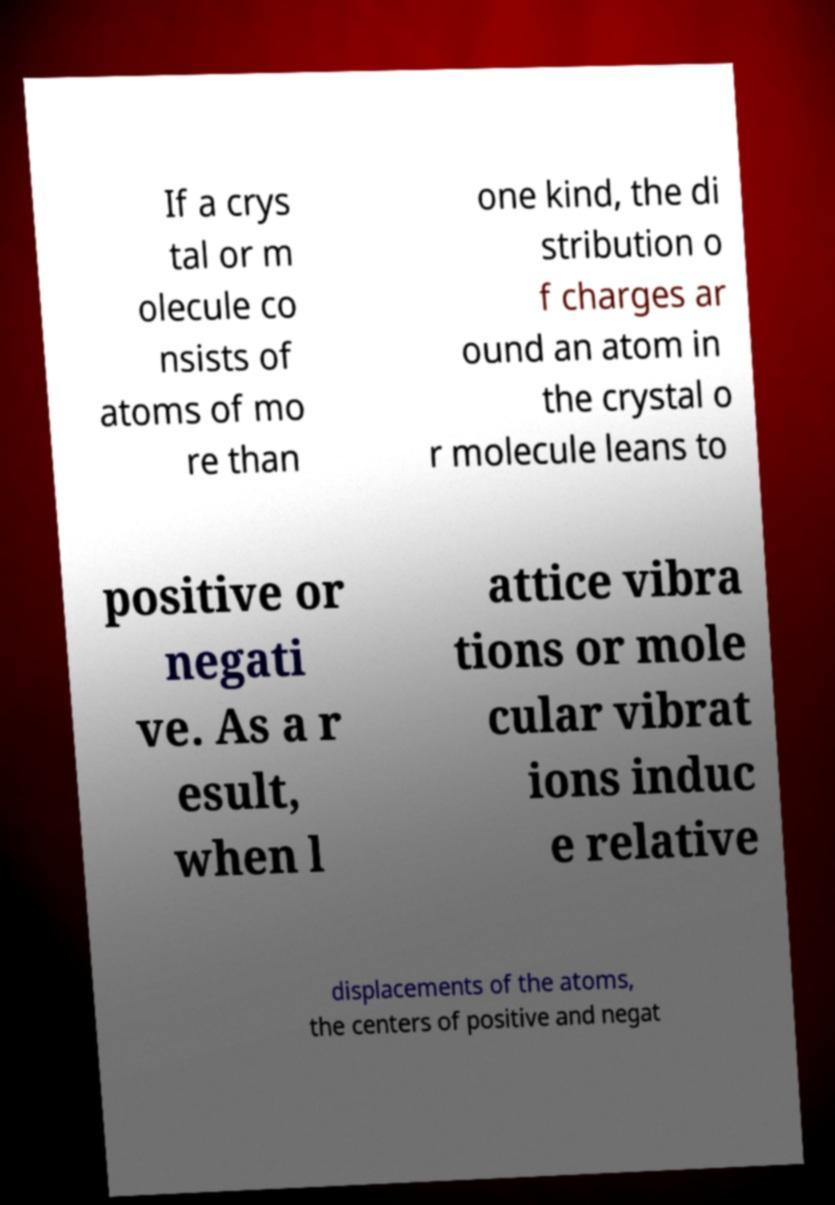Can you read and provide the text displayed in the image?This photo seems to have some interesting text. Can you extract and type it out for me? If a crys tal or m olecule co nsists of atoms of mo re than one kind, the di stribution o f charges ar ound an atom in the crystal o r molecule leans to positive or negati ve. As a r esult, when l attice vibra tions or mole cular vibrat ions induc e relative displacements of the atoms, the centers of positive and negat 